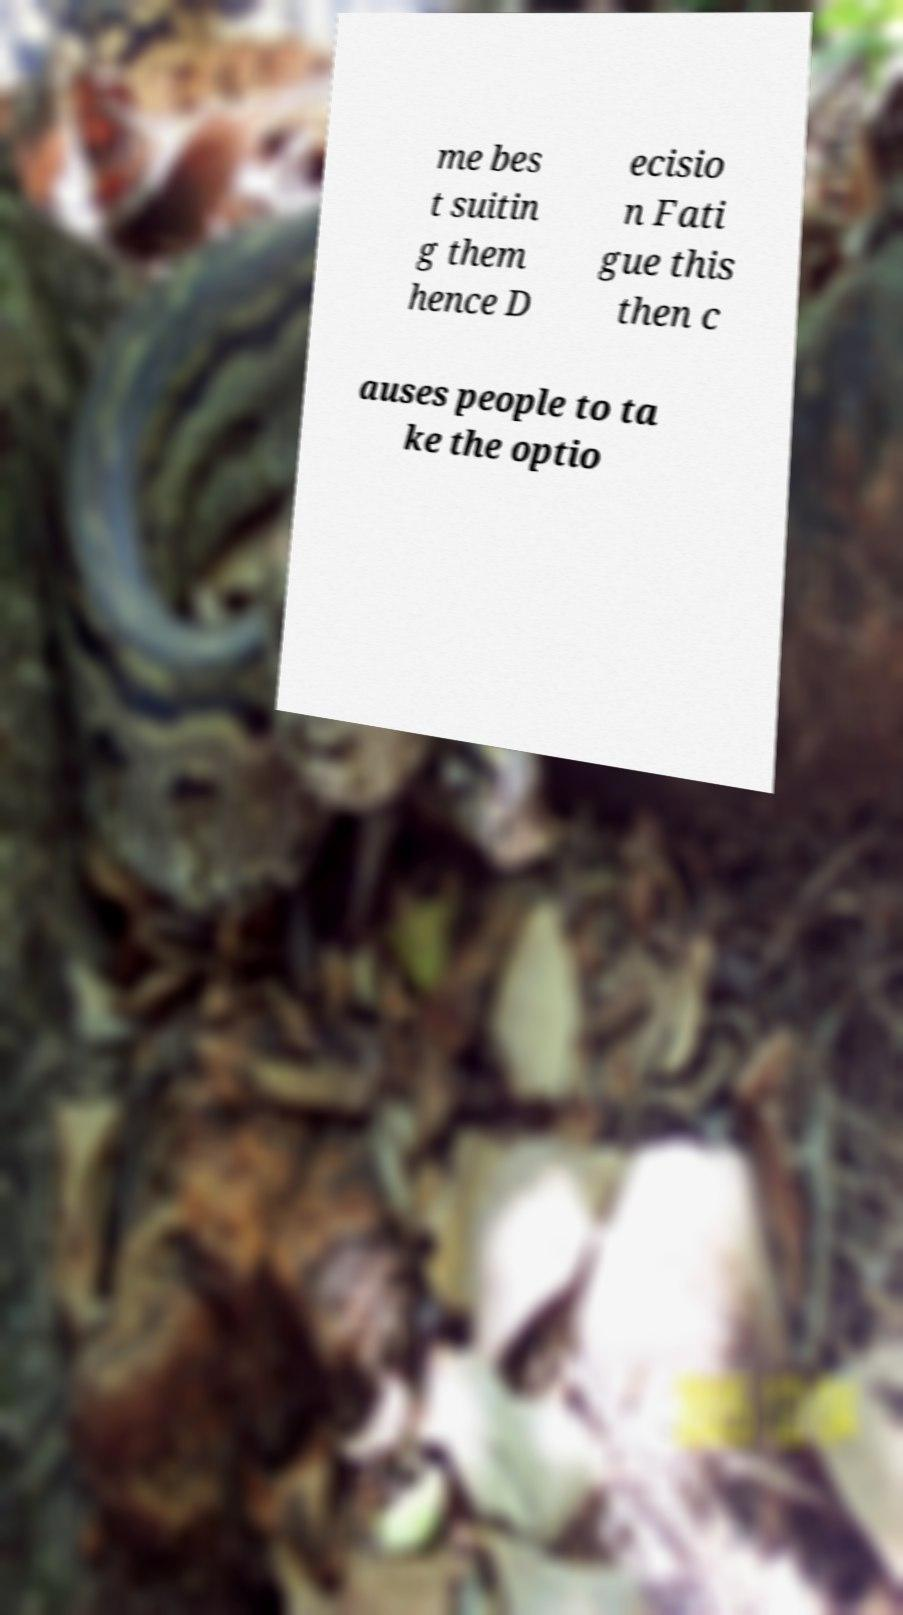For documentation purposes, I need the text within this image transcribed. Could you provide that? me bes t suitin g them hence D ecisio n Fati gue this then c auses people to ta ke the optio 